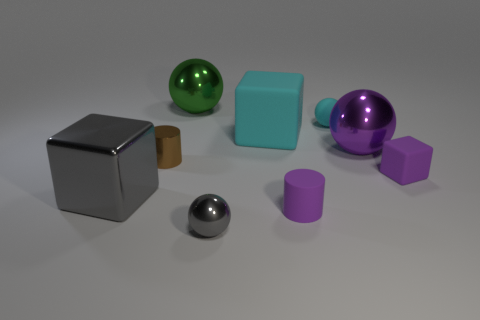Subtract all balls. How many objects are left? 5 Add 9 tiny cyan rubber balls. How many tiny cyan rubber balls are left? 10 Add 3 small cubes. How many small cubes exist? 4 Subtract 0 blue cylinders. How many objects are left? 9 Subtract all large gray balls. Subtract all large gray metallic cubes. How many objects are left? 8 